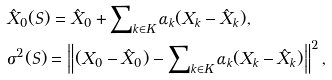Convert formula to latex. <formula><loc_0><loc_0><loc_500><loc_500>& \hat { X } _ { 0 } ( S ) = \hat { X } _ { 0 } + \sum \nolimits _ { k \in K } \alpha _ { k } ( X _ { k } - \hat { X } _ { k } ) , \\ & \sigma ^ { 2 } ( S ) = \left \| ( X _ { 0 } - \hat { X } _ { 0 } ) - \sum \nolimits _ { k \in K } \alpha _ { k } ( X _ { k } - \hat { X } _ { k } ) \right \| ^ { 2 } ,</formula> 